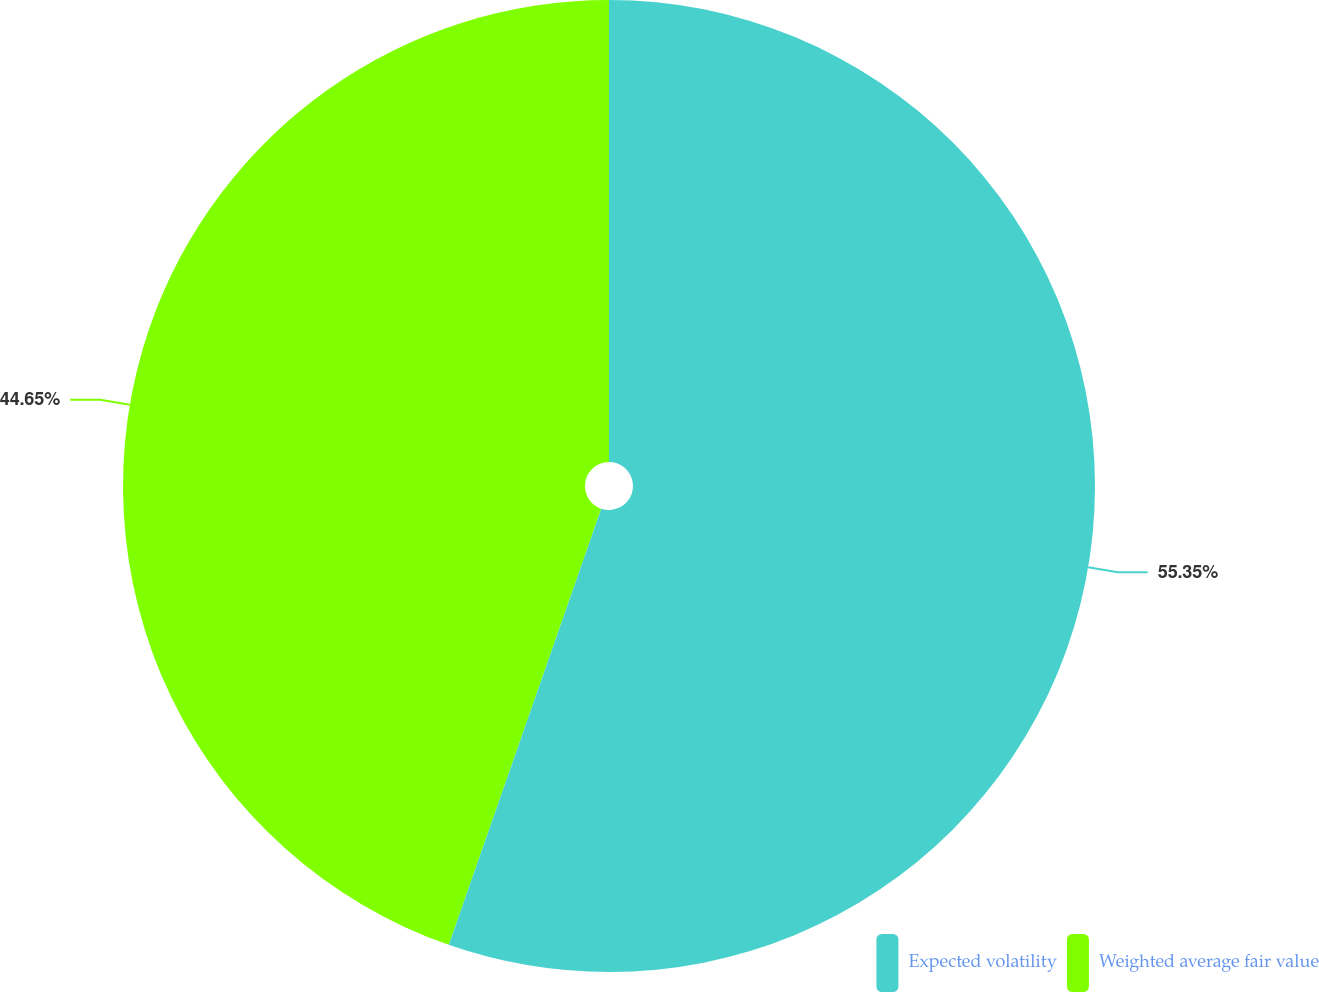Convert chart to OTSL. <chart><loc_0><loc_0><loc_500><loc_500><pie_chart><fcel>Expected volatility<fcel>Weighted average fair value<nl><fcel>55.35%<fcel>44.65%<nl></chart> 